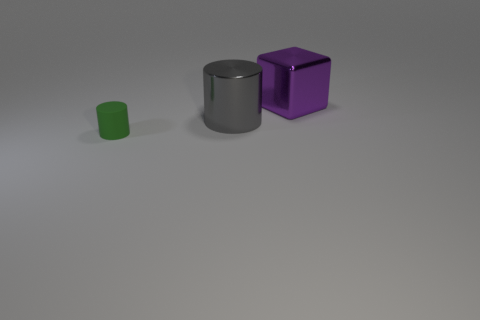Add 1 gray things. How many objects exist? 4 Subtract all blocks. How many objects are left? 2 Subtract 0 gray spheres. How many objects are left? 3 Subtract all cylinders. Subtract all large cylinders. How many objects are left? 0 Add 3 big gray cylinders. How many big gray cylinders are left? 4 Add 3 tiny green cylinders. How many tiny green cylinders exist? 4 